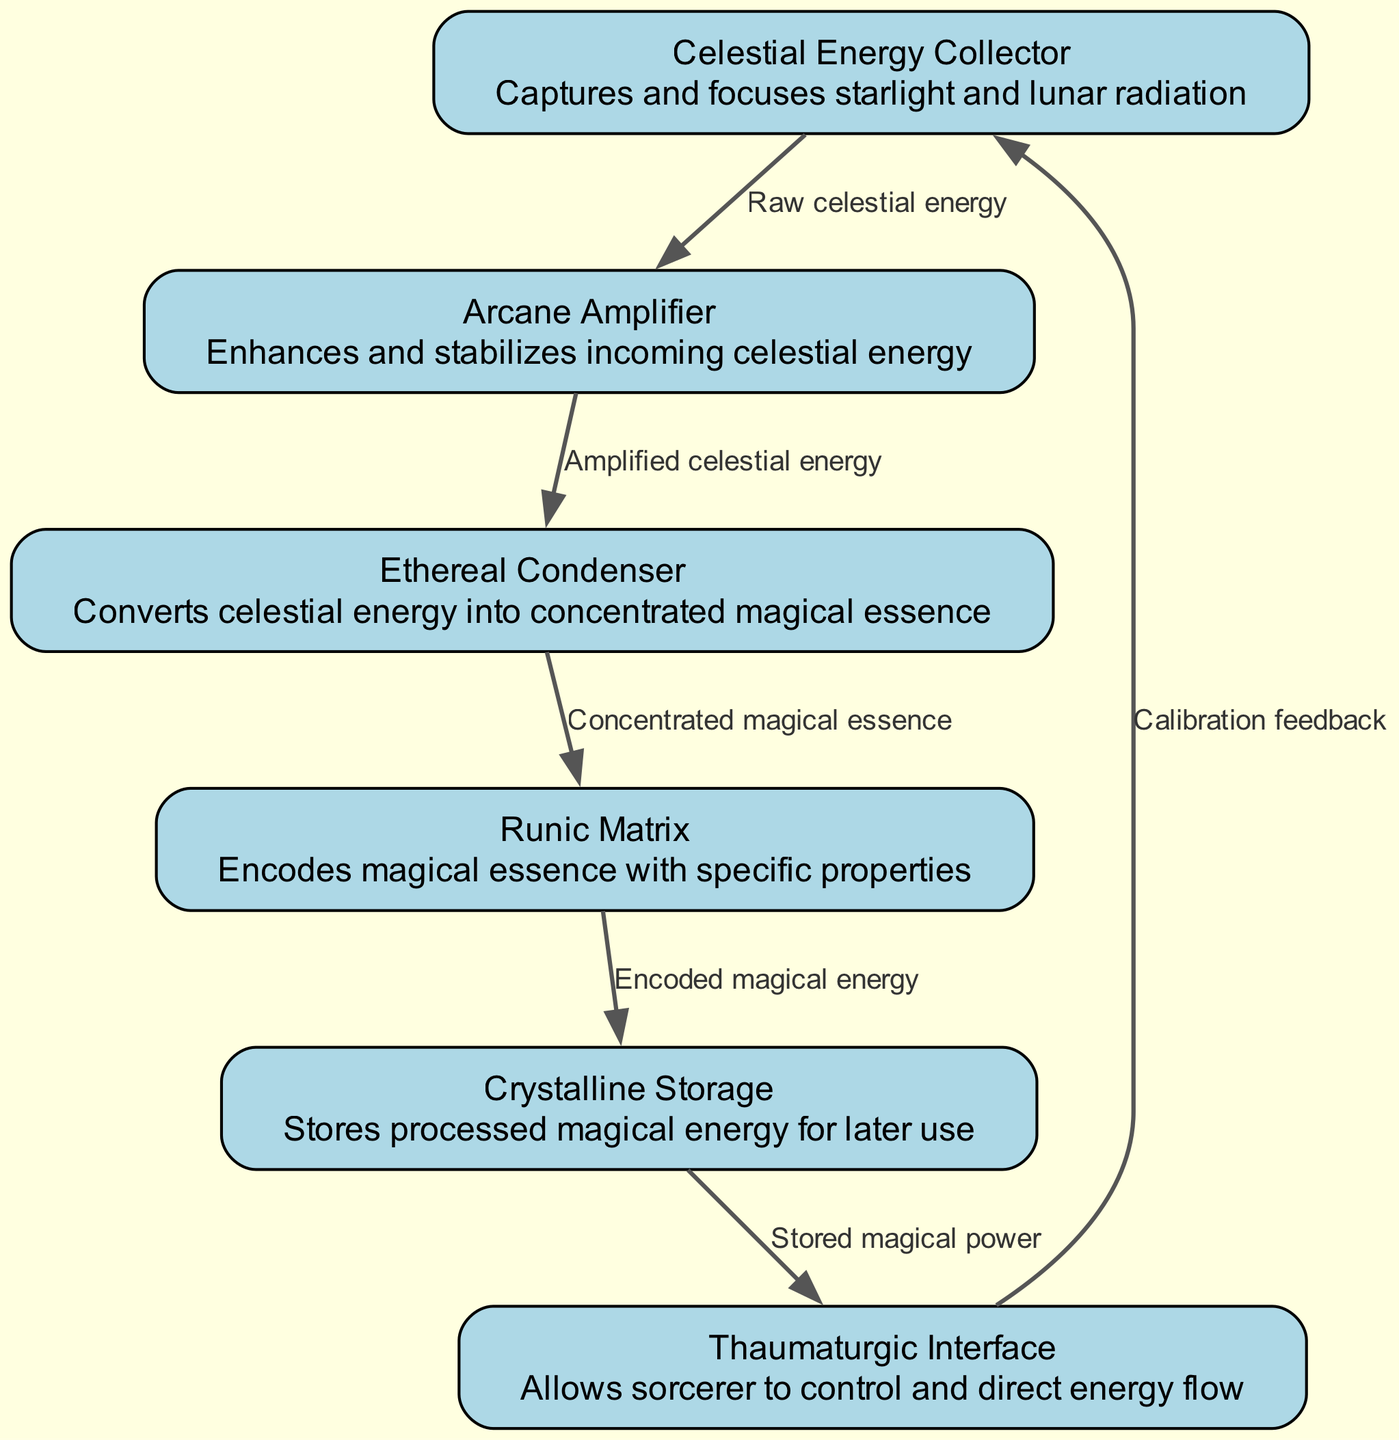What is the first component in the energy conversion process? The diagram identifies the "Celestial Energy Collector" as the first node, which is responsible for capturing celestial energy.
Answer: Celestial Energy Collector How many nodes are present in the diagram? By counting the listed nodes, we find there are six distinct components contributing to the energy conversion process.
Answer: 6 Which component encodes the magical essence? The "Runic Matrix" serves the purpose of encoding the properties of the magical essence, acting as an intermediary in the conversion process.
Answer: Runic Matrix What type of energy does the Arcane Amplifier enhance? The Arcane Amplifier enhances and stabilizes the "Amplified celestial energy," which is the energy transitioning from the Celestial Energy Collector.
Answer: Amplified celestial energy What is the direct output of the Ethereal Condenser? The output from the Ethereal Condenser is "Concentrated magical essence," which signifies its role in transforming the captured energy into a more usable form.
Answer: Concentrated magical essence Which component receives feedback for calibration? The "Thaumaturgic Interface" receives "Calibration feedback" from the Crystalline Storage component, indicating a cyclical interaction in the energy management process.
Answer: Thaumaturgic Interface What is the final destination of the stored magical power? The stored magical power is utilized by the Thaumaturgic Interface, which emphasizes its function in harnessing the converted energy for magical endeavors.
Answer: Thaumaturgic Interface How many edges connect the components in the schematic? The schematic features five connections between the components, illustrating the flow of energy from one node to another.
Answer: 5 What is the main function of the Crystalline Storage? The Crystalline Storage is designated for storing "Processed magical energy," crucial for later utilization in magical operations.
Answer: Processed magical energy 